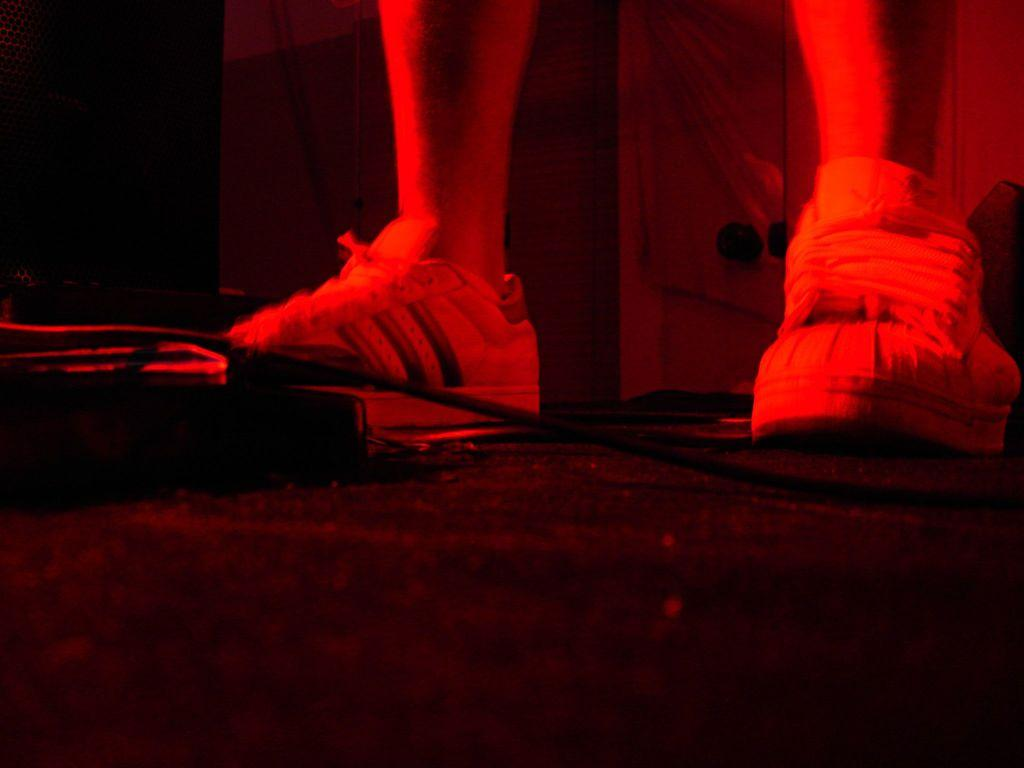What body parts are visible in the image? There are human legs visible in the image. Where are the human legs located? The human legs are on the ground. What type of mark can be seen on the ant in the image? There is no ant present in the image, and therefore no mark can be observed on it. 